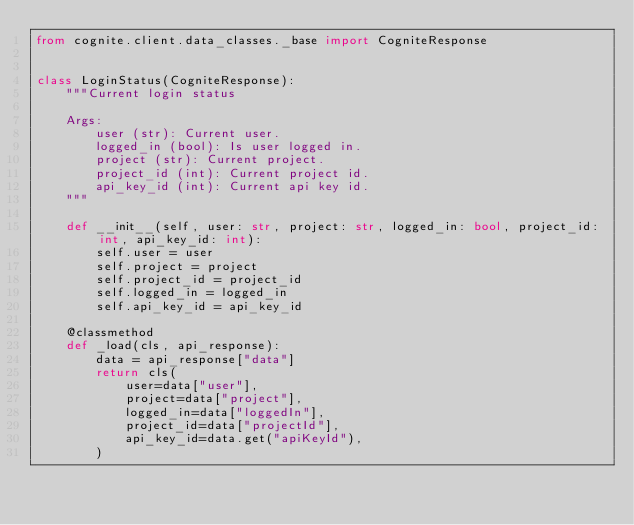Convert code to text. <code><loc_0><loc_0><loc_500><loc_500><_Python_>from cognite.client.data_classes._base import CogniteResponse


class LoginStatus(CogniteResponse):
    """Current login status

    Args:
        user (str): Current user.
        logged_in (bool): Is user logged in.
        project (str): Current project.
        project_id (int): Current project id.
        api_key_id (int): Current api key id.
    """

    def __init__(self, user: str, project: str, logged_in: bool, project_id: int, api_key_id: int):
        self.user = user
        self.project = project
        self.project_id = project_id
        self.logged_in = logged_in
        self.api_key_id = api_key_id

    @classmethod
    def _load(cls, api_response):
        data = api_response["data"]
        return cls(
            user=data["user"],
            project=data["project"],
            logged_in=data["loggedIn"],
            project_id=data["projectId"],
            api_key_id=data.get("apiKeyId"),
        )
</code> 